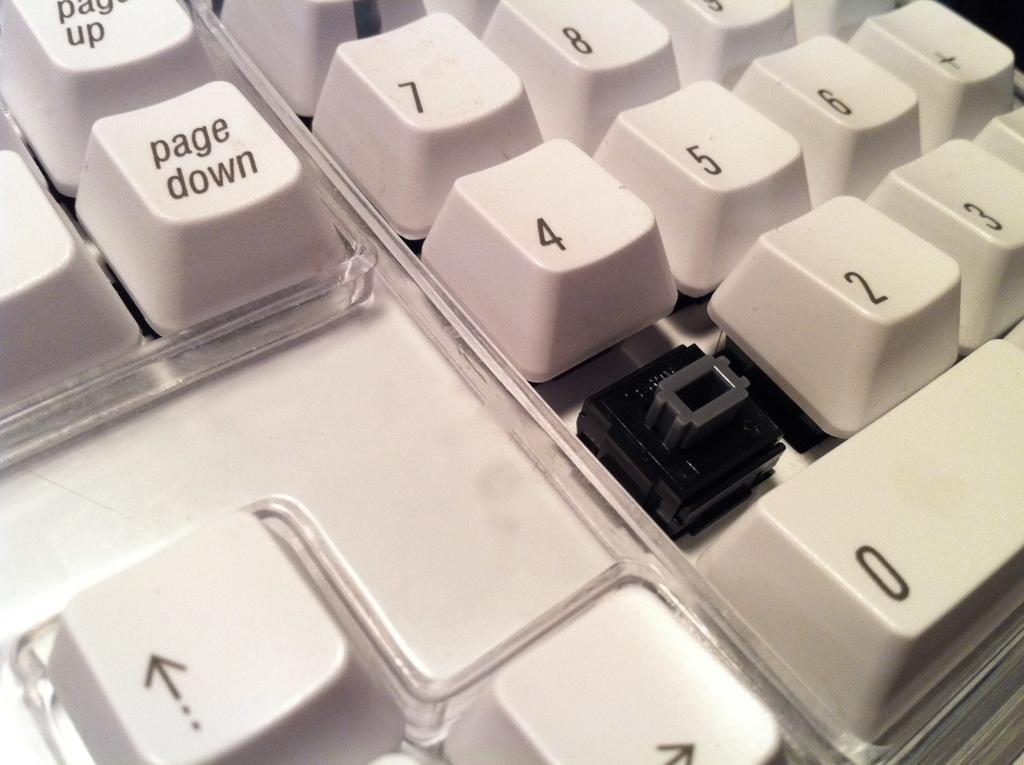What number key is missing?
Make the answer very short. 1. 